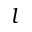<formula> <loc_0><loc_0><loc_500><loc_500>l</formula> 